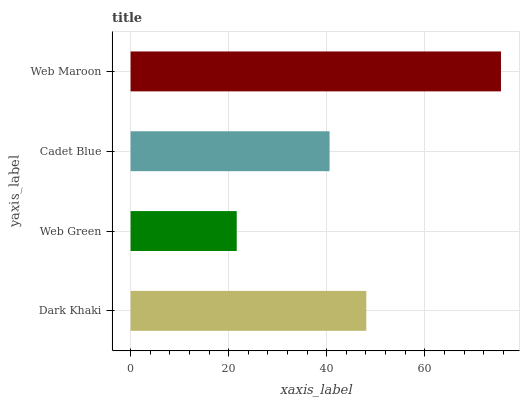Is Web Green the minimum?
Answer yes or no. Yes. Is Web Maroon the maximum?
Answer yes or no. Yes. Is Cadet Blue the minimum?
Answer yes or no. No. Is Cadet Blue the maximum?
Answer yes or no. No. Is Cadet Blue greater than Web Green?
Answer yes or no. Yes. Is Web Green less than Cadet Blue?
Answer yes or no. Yes. Is Web Green greater than Cadet Blue?
Answer yes or no. No. Is Cadet Blue less than Web Green?
Answer yes or no. No. Is Dark Khaki the high median?
Answer yes or no. Yes. Is Cadet Blue the low median?
Answer yes or no. Yes. Is Web Green the high median?
Answer yes or no. No. Is Dark Khaki the low median?
Answer yes or no. No. 